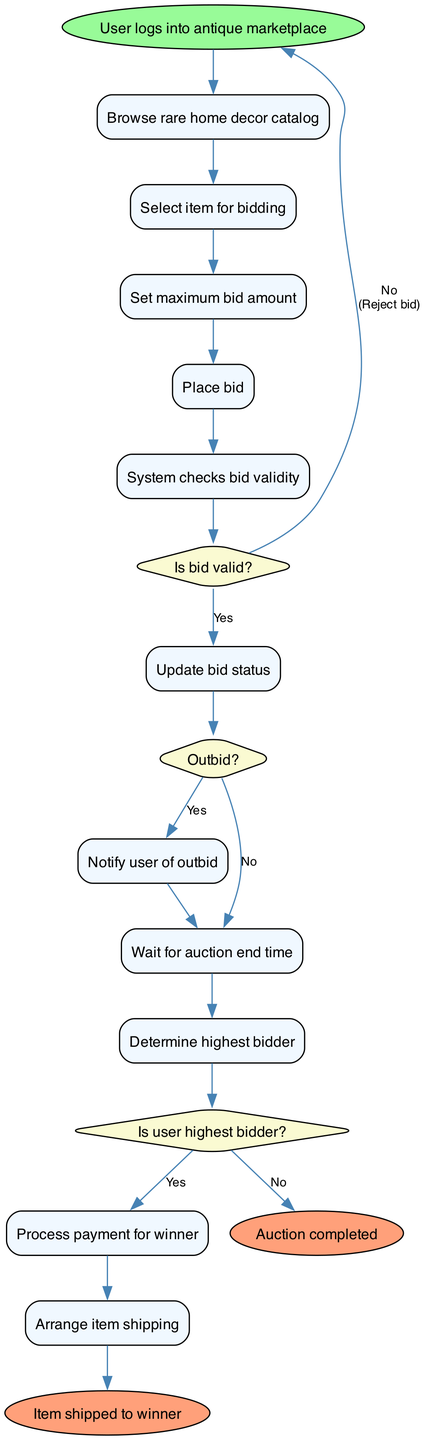What is the first activity in the auction process? The diagram begins with the first activity labeled as "User logs into antique marketplace," indicating that this is the very first step in the auction bidding process.
Answer: User logs into antique marketplace How many decision nodes are in the diagram? The diagram contains three decision nodes labeled with conditions for bid validity, outbid status, and highest bidder determination. Therefore, the total count of decision nodes is three.
Answer: 3 What happens if the bid is invalid? According to the flow of the diagram, if the bid is determined to be invalid (No from the "Is bid valid?" decision), the process directs to the "Reject bid" action, indicating that the user's bid would not be accepted.
Answer: Reject bid What is the final outcome if the payment is processed successfully? If the payment for the highest bidder is processed successfully, the next step in the flow is to arrange item shipping, indicating the successful conclusion of the auction process for that item.
Answer: Arrange item shipping What is the node that occurs after the auction end time? Following the auction end time, the next action is to "Determine highest bidder," which means that this step is crucial for concluding the auction successfully.
Answer: Determine highest bidder What happens if the user is not the highest bidder? If the user is not the highest bidder (No from the "Is user highest bidder?" decision), they receive a notification of auction loss, indicating they did not win the item in question.
Answer: Notify user of auction loss What denotes the start of the auction process? The start of the auction process is denoted by the "start" node, which indicates the initiation point for all subsequent activities in the auction diagram.
Answer: start What is the last step in the activity diagram? The last step in the activity diagram after all processes are concluded is represented as "Item shipped to winner," finalizing the auction process by indicating that the item has been dispatched to the winning bidder.
Answer: Item shipped to winner 